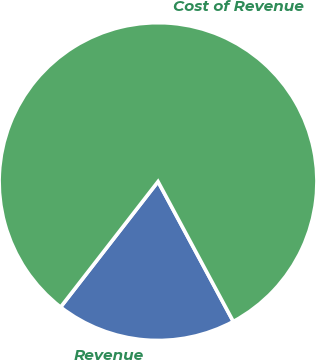Convert chart to OTSL. <chart><loc_0><loc_0><loc_500><loc_500><pie_chart><fcel>Revenue<fcel>Cost of Revenue<nl><fcel>18.36%<fcel>81.64%<nl></chart> 